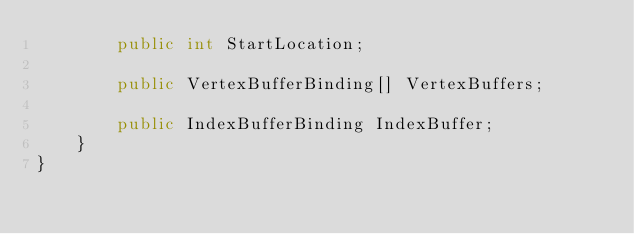Convert code to text. <code><loc_0><loc_0><loc_500><loc_500><_C#_>        public int StartLocation;

        public VertexBufferBinding[] VertexBuffers;

        public IndexBufferBinding IndexBuffer;
    }
}
</code> 